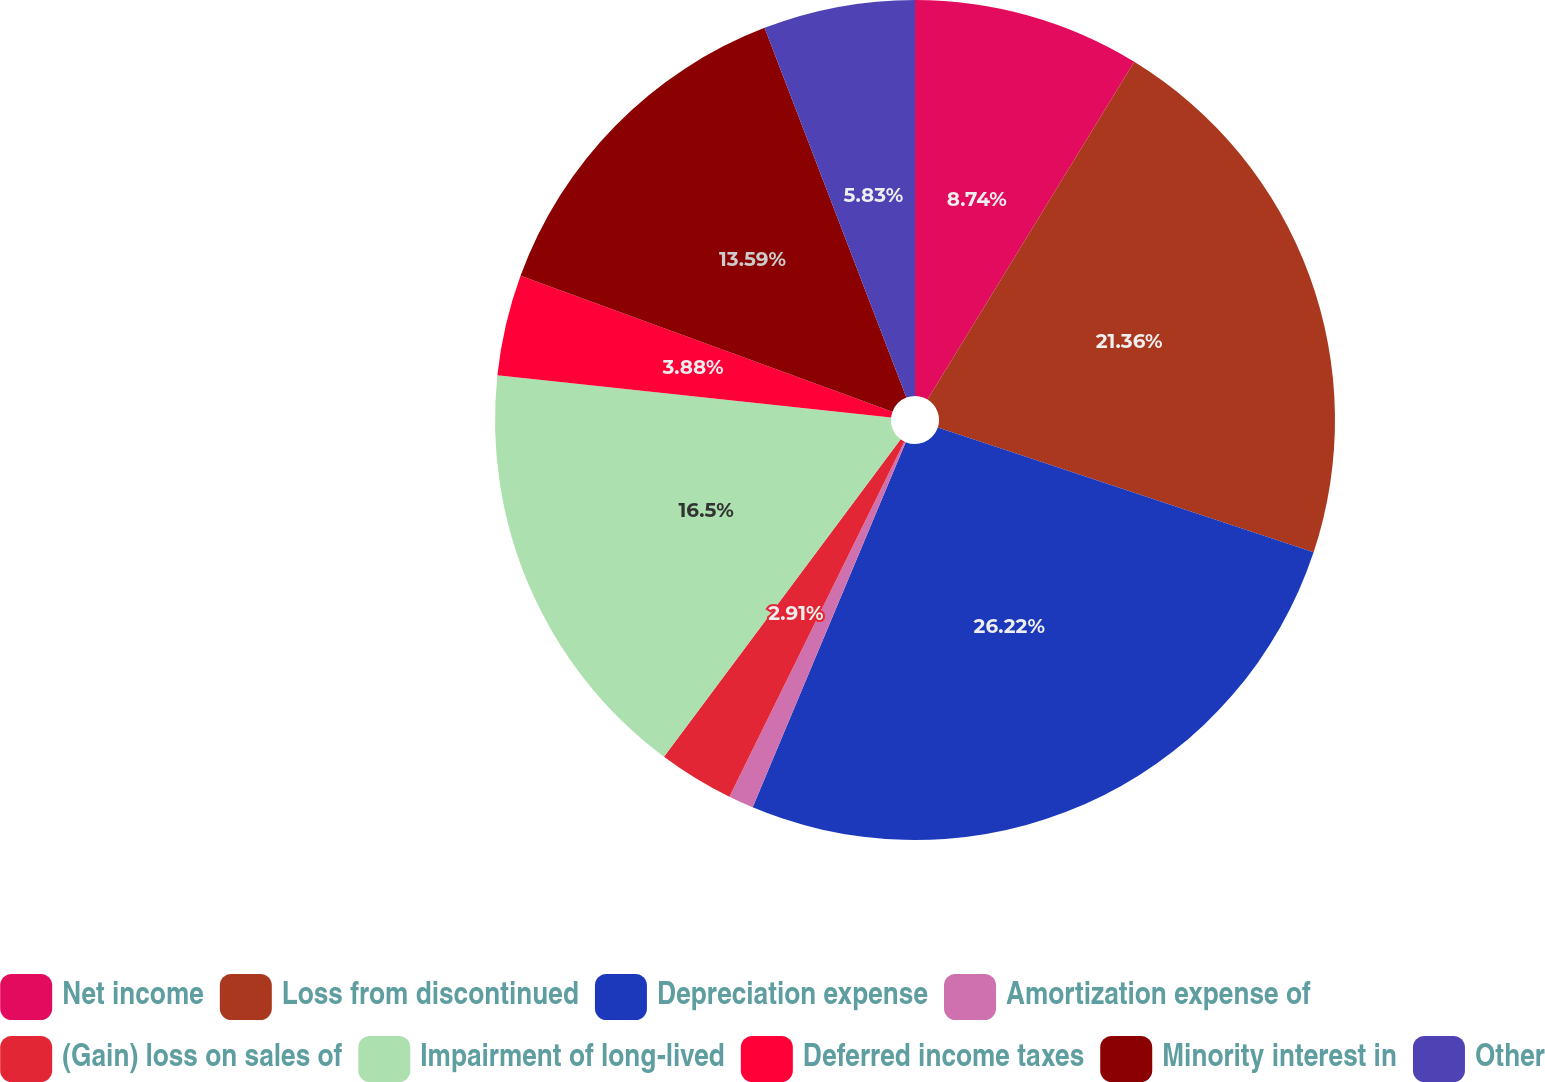Convert chart to OTSL. <chart><loc_0><loc_0><loc_500><loc_500><pie_chart><fcel>Net income<fcel>Loss from discontinued<fcel>Depreciation expense<fcel>Amortization expense of<fcel>(Gain) loss on sales of<fcel>Impairment of long-lived<fcel>Deferred income taxes<fcel>Minority interest in<fcel>Other<nl><fcel>8.74%<fcel>21.36%<fcel>26.21%<fcel>0.97%<fcel>2.91%<fcel>16.5%<fcel>3.88%<fcel>13.59%<fcel>5.83%<nl></chart> 